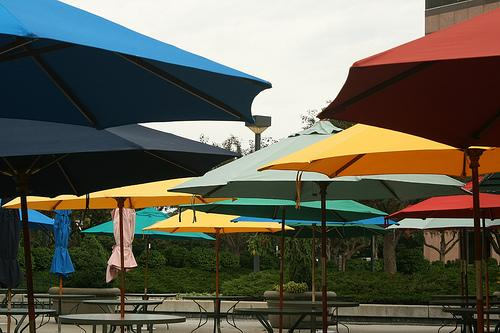Identify two contrasting colors of umbrellas visible in the photo. There are open red and yellow umbrellas, offering a visual contrast on the patio. Identify the primary objects in the image and their qualities. The image features various open and closed patio umbrellas of different colors (red, yellow, blue) with wooden ribs, providing shade for round metal tables surrounded by neatly trimmed bushes and cement planters. In a short sentence, describe the atmosphere of the outdoor setting. A pleasant patio with colorful shade umbrellas, tables, and greenery on a cloudy day. How is the weather condition described in the photo? The photo was taken on a cloudy day with a grey overcast sky. Compare the open and closed umbrella characteristics in the image. Open umbrellas are red, yellow, or blue and cover the tables, while closed umbrellas are off white or blue without functional purpose. What color and state are the majority of the umbrellas, and what purpose do they serve? The majority of umbrellas are open and multicolored (red, yellow, blue), providing shade for the tables on the patio. What kind of surfaces are the bushes planted in and describe their positions? The bushes are planted in concrete pots and a cement planter and located by the patio wall as well as in the background. What materials are mentioned in the descriptions of the objects in the image? Wood (for umbrella poles), cement (for pots and wall), and metal (for tables) are mentioned. 